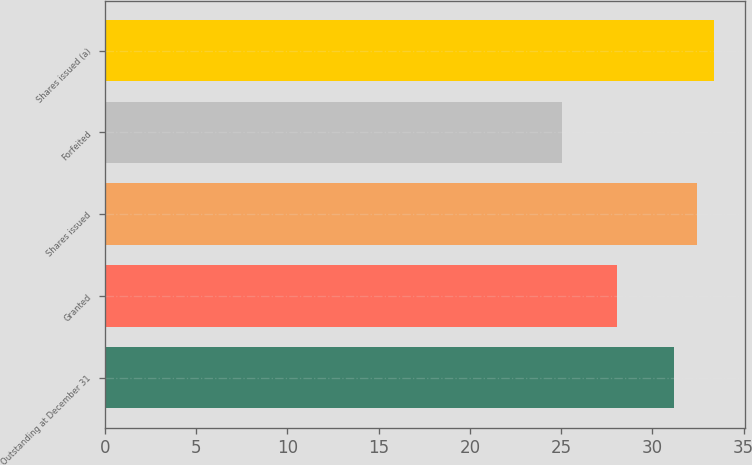<chart> <loc_0><loc_0><loc_500><loc_500><bar_chart><fcel>Outstanding at December 31<fcel>Granted<fcel>Shares issued<fcel>Forfeited<fcel>Shares issued (a)<nl><fcel>31.2<fcel>28.04<fcel>32.43<fcel>25.07<fcel>33.39<nl></chart> 